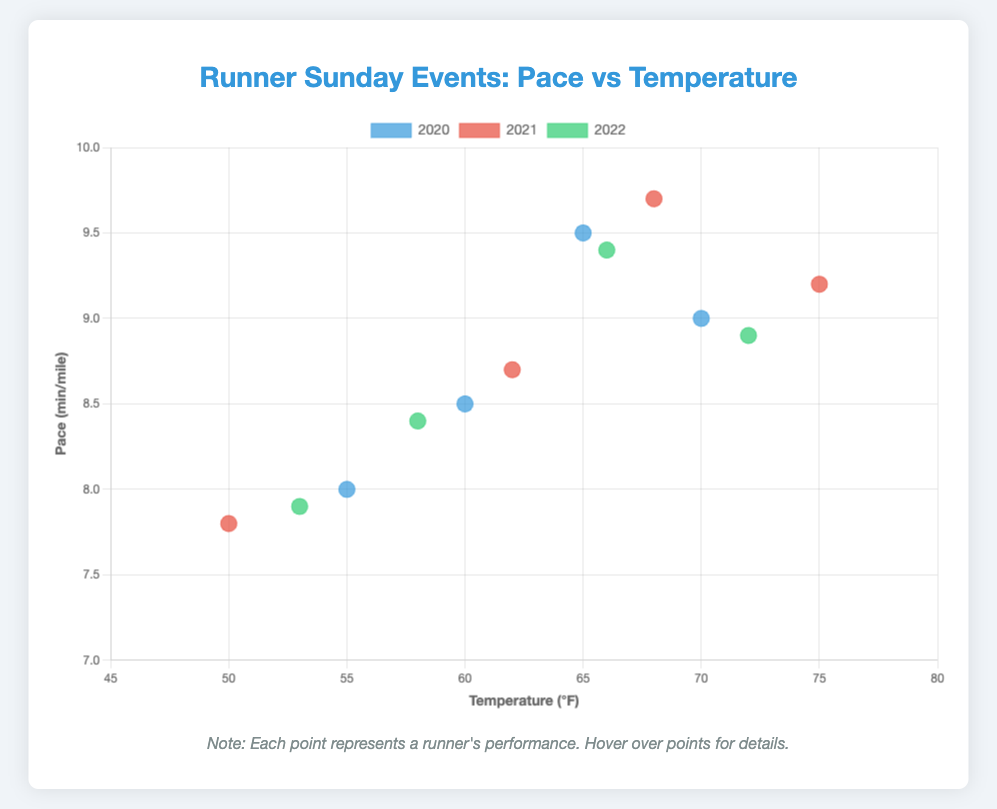What is the title of the figure? The title of the figure is displayed at the top and it reads "Runner Sunday Events: Pace vs Temperature".
Answer: "Runner Sunday Events: Pace vs Temperature" What are the units used for temperature on the x-axis? The units for temperature on the x-axis are shown in parentheses in the axis label, which is in degrees Fahrenheit (°F).
Answer: °F How many runners participated in the events for the year 2020? Each data point represents one runner, and there are four data points for the year 2020.
Answer: 4 Which year, on average, had the fastest running pace? To find the answer, we need to calculate the average pace for each year. For 2020: (8.5 + 9.0 + 8.0 + 9.5) / 4 = 8.75 min/mile. For 2021: (8.7 + 9.2 + 7.8 + 9.7) / 4 = 8.85 min/mile. For 2022: (8.4 + 8.9 + 7.9 + 9.4) / 4 = 8.65 min/mile. The fastest average pace is 8.65 min/mile in 2022.
Answer: 2022 Does Alice's running pace improve over these three years? Check Alice's pace for each year: 2020: 8.5 min/mile, 2021: 8.7 min/mile, 2022: 8.4 min/mile. From 2020 to 2021, her pace slowed, but from 2021 to 2022, it improved. Overall, it improved from 8.5 min/mile to 8.4 min/mile.
Answer: Yes In which year did Bob have the fastest running pace, and at what temperature? For Bob: 2020: 9.0 min/mile (70°F), 2021: 9.2 min/mile (75°F), 2022: 8.9 min/mile (72°F). Bob had his fastest pace in 2022 at 72°F.
Answer: 2022, 72°F What is the relationship between Charlie's pace and the temperature? Observing Charlie's data points across different years: 2020: 8.0 min/mile (55°F), 2021: 7.8 min/mile (50°F), 2022: 7.9 min/mile (53°F). As the temperature decreases, Charlie’s pace improves slightly.
Answer: Faster at lower temperatures Which runner showed the most fluctuation in their performance across the three years? To determine this, compare the pace variance for each runner. Alice: 8.5, 8.7, 8.4 (range: 0.3); Bob: 9.0, 9.2, 8.9 (range: 0.3); Charlie: 8.0, 7.8, 7.9 (range: 0.2); Della: 9.5, 9.7, 9.4 (range: 0.3). All runners have a similar range of 0.3, but Della has a higher pace range.
Answer: Della 